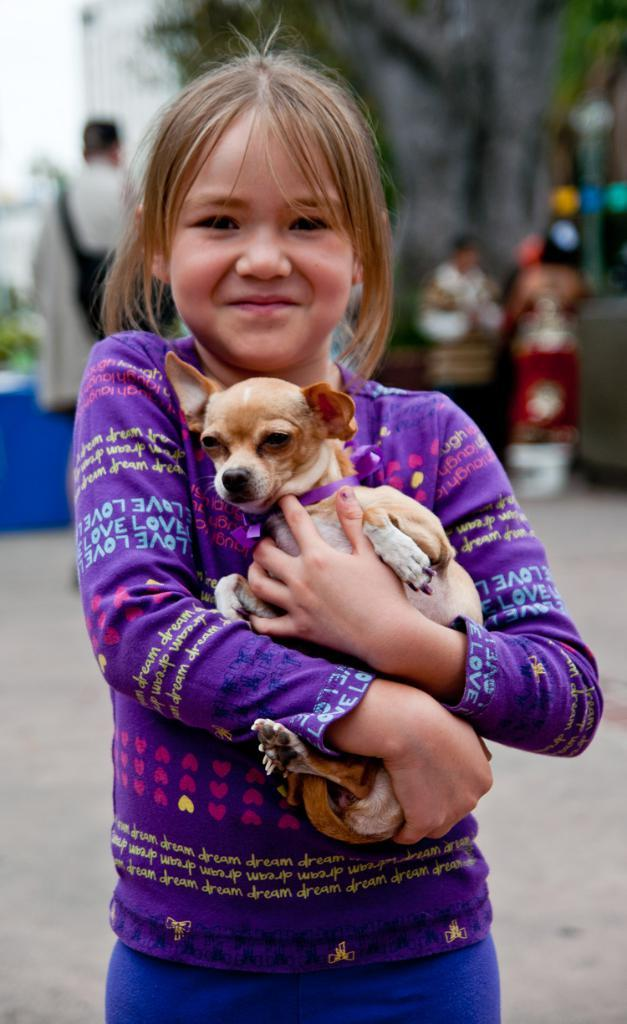Who is the main subject in the image? There is a girl in the image. What is the girl wearing? The girl is wearing a violet t-shirt and trousers. What is the girl holding in the image? The girl is holding a dog. Can you describe the girl's hair? The girl has short hair. What else can be seen in the background of the image? There are people in the background of the image. What type of apparatus can be seen in the girl's hand in the image? There is no apparatus visible in the girl's hand in the image; she is holding a dog. What time is it according to the clocks in the image? There are no clocks present in the image. 